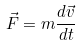Convert formula to latex. <formula><loc_0><loc_0><loc_500><loc_500>\vec { F } = m \frac { d \vec { v } } { d t }</formula> 